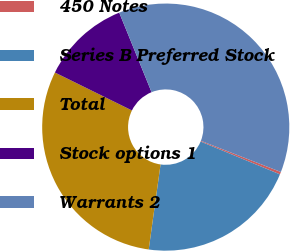Convert chart to OTSL. <chart><loc_0><loc_0><loc_500><loc_500><pie_chart><fcel>450 Notes<fcel>Series B Preferred Stock<fcel>Total<fcel>Stock options 1<fcel>Warrants 2<nl><fcel>0.33%<fcel>20.96%<fcel>30.08%<fcel>11.57%<fcel>37.06%<nl></chart> 